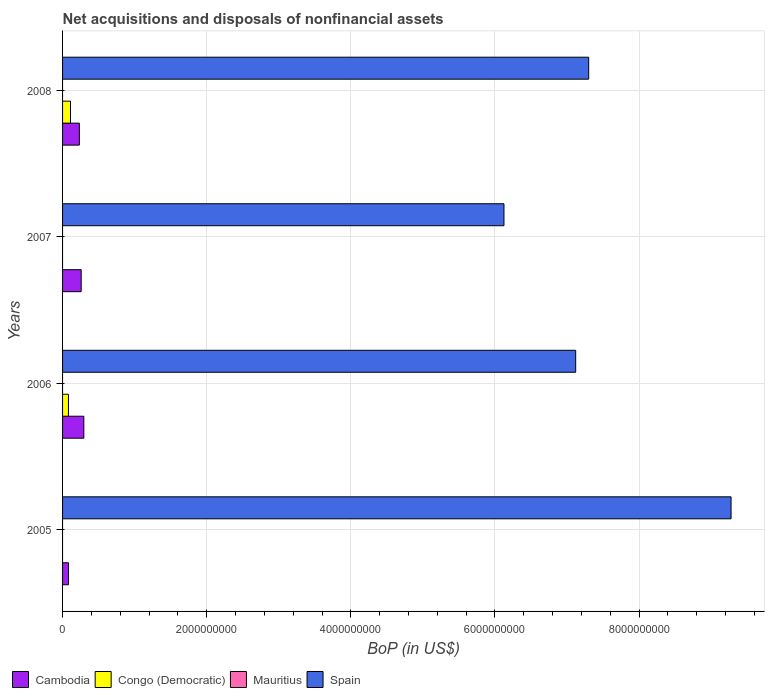How many groups of bars are there?
Ensure brevity in your answer.  4. Are the number of bars per tick equal to the number of legend labels?
Provide a short and direct response. No. How many bars are there on the 3rd tick from the bottom?
Offer a very short reply. 2. What is the label of the 3rd group of bars from the top?
Provide a succinct answer. 2006. In how many cases, is the number of bars for a given year not equal to the number of legend labels?
Keep it short and to the point. 4. What is the Balance of Payments in Congo (Democratic) in 2005?
Your answer should be very brief. 0. Across all years, what is the maximum Balance of Payments in Cambodia?
Offer a very short reply. 2.95e+08. Across all years, what is the minimum Balance of Payments in Spain?
Provide a short and direct response. 6.12e+09. In which year was the Balance of Payments in Cambodia maximum?
Your answer should be very brief. 2006. What is the total Balance of Payments in Spain in the graph?
Your answer should be compact. 2.98e+1. What is the difference between the Balance of Payments in Spain in 2007 and that in 2008?
Offer a terse response. -1.18e+09. What is the difference between the Balance of Payments in Mauritius in 2005 and the Balance of Payments in Congo (Democratic) in 2008?
Give a very brief answer. -1.10e+08. What is the average Balance of Payments in Spain per year?
Give a very brief answer. 7.46e+09. In the year 2008, what is the difference between the Balance of Payments in Spain and Balance of Payments in Cambodia?
Your answer should be compact. 7.07e+09. In how many years, is the Balance of Payments in Cambodia greater than 1600000000 US$?
Ensure brevity in your answer.  0. What is the ratio of the Balance of Payments in Spain in 2005 to that in 2008?
Your answer should be compact. 1.27. Is the difference between the Balance of Payments in Spain in 2005 and 2008 greater than the difference between the Balance of Payments in Cambodia in 2005 and 2008?
Your answer should be very brief. Yes. What is the difference between the highest and the second highest Balance of Payments in Cambodia?
Make the answer very short. 3.66e+07. What is the difference between the highest and the lowest Balance of Payments in Spain?
Give a very brief answer. 3.15e+09. In how many years, is the Balance of Payments in Spain greater than the average Balance of Payments in Spain taken over all years?
Give a very brief answer. 1. Is the sum of the Balance of Payments in Cambodia in 2005 and 2006 greater than the maximum Balance of Payments in Congo (Democratic) across all years?
Offer a terse response. Yes. How many years are there in the graph?
Offer a terse response. 4. What is the difference between two consecutive major ticks on the X-axis?
Your answer should be compact. 2.00e+09. Does the graph contain any zero values?
Provide a succinct answer. Yes. Does the graph contain grids?
Ensure brevity in your answer.  Yes. Where does the legend appear in the graph?
Ensure brevity in your answer.  Bottom left. How many legend labels are there?
Keep it short and to the point. 4. How are the legend labels stacked?
Ensure brevity in your answer.  Horizontal. What is the title of the graph?
Provide a short and direct response. Net acquisitions and disposals of nonfinancial assets. What is the label or title of the X-axis?
Keep it short and to the point. BoP (in US$). What is the label or title of the Y-axis?
Your answer should be compact. Years. What is the BoP (in US$) in Cambodia in 2005?
Give a very brief answer. 8.26e+07. What is the BoP (in US$) in Spain in 2005?
Ensure brevity in your answer.  9.28e+09. What is the BoP (in US$) of Cambodia in 2006?
Provide a succinct answer. 2.95e+08. What is the BoP (in US$) in Congo (Democratic) in 2006?
Ensure brevity in your answer.  8.17e+07. What is the BoP (in US$) in Mauritius in 2006?
Offer a very short reply. 0. What is the BoP (in US$) in Spain in 2006?
Provide a short and direct response. 7.12e+09. What is the BoP (in US$) in Cambodia in 2007?
Make the answer very short. 2.58e+08. What is the BoP (in US$) in Congo (Democratic) in 2007?
Your answer should be compact. 0. What is the BoP (in US$) in Spain in 2007?
Give a very brief answer. 6.12e+09. What is the BoP (in US$) of Cambodia in 2008?
Offer a very short reply. 2.33e+08. What is the BoP (in US$) in Congo (Democratic) in 2008?
Give a very brief answer. 1.10e+08. What is the BoP (in US$) in Spain in 2008?
Offer a terse response. 7.30e+09. Across all years, what is the maximum BoP (in US$) of Cambodia?
Offer a very short reply. 2.95e+08. Across all years, what is the maximum BoP (in US$) of Congo (Democratic)?
Keep it short and to the point. 1.10e+08. Across all years, what is the maximum BoP (in US$) in Spain?
Your answer should be compact. 9.28e+09. Across all years, what is the minimum BoP (in US$) in Cambodia?
Provide a short and direct response. 8.26e+07. Across all years, what is the minimum BoP (in US$) in Congo (Democratic)?
Provide a succinct answer. 0. Across all years, what is the minimum BoP (in US$) of Spain?
Your answer should be compact. 6.12e+09. What is the total BoP (in US$) of Cambodia in the graph?
Provide a short and direct response. 8.69e+08. What is the total BoP (in US$) of Congo (Democratic) in the graph?
Your answer should be very brief. 1.92e+08. What is the total BoP (in US$) in Spain in the graph?
Offer a terse response. 2.98e+1. What is the difference between the BoP (in US$) in Cambodia in 2005 and that in 2006?
Offer a very short reply. -2.12e+08. What is the difference between the BoP (in US$) of Spain in 2005 and that in 2006?
Your answer should be very brief. 2.16e+09. What is the difference between the BoP (in US$) in Cambodia in 2005 and that in 2007?
Your answer should be very brief. -1.76e+08. What is the difference between the BoP (in US$) in Spain in 2005 and that in 2007?
Make the answer very short. 3.15e+09. What is the difference between the BoP (in US$) in Cambodia in 2005 and that in 2008?
Ensure brevity in your answer.  -1.50e+08. What is the difference between the BoP (in US$) of Spain in 2005 and that in 2008?
Provide a short and direct response. 1.98e+09. What is the difference between the BoP (in US$) of Cambodia in 2006 and that in 2007?
Your answer should be compact. 3.66e+07. What is the difference between the BoP (in US$) in Spain in 2006 and that in 2007?
Provide a succinct answer. 9.95e+08. What is the difference between the BoP (in US$) of Cambodia in 2006 and that in 2008?
Give a very brief answer. 6.22e+07. What is the difference between the BoP (in US$) of Congo (Democratic) in 2006 and that in 2008?
Your answer should be very brief. -2.84e+07. What is the difference between the BoP (in US$) in Spain in 2006 and that in 2008?
Your response must be concise. -1.81e+08. What is the difference between the BoP (in US$) of Cambodia in 2007 and that in 2008?
Ensure brevity in your answer.  2.56e+07. What is the difference between the BoP (in US$) in Spain in 2007 and that in 2008?
Make the answer very short. -1.18e+09. What is the difference between the BoP (in US$) of Cambodia in 2005 and the BoP (in US$) of Congo (Democratic) in 2006?
Provide a succinct answer. 8.53e+05. What is the difference between the BoP (in US$) of Cambodia in 2005 and the BoP (in US$) of Spain in 2006?
Give a very brief answer. -7.04e+09. What is the difference between the BoP (in US$) in Cambodia in 2005 and the BoP (in US$) in Spain in 2007?
Keep it short and to the point. -6.04e+09. What is the difference between the BoP (in US$) of Cambodia in 2005 and the BoP (in US$) of Congo (Democratic) in 2008?
Your answer should be compact. -2.75e+07. What is the difference between the BoP (in US$) of Cambodia in 2005 and the BoP (in US$) of Spain in 2008?
Provide a short and direct response. -7.22e+09. What is the difference between the BoP (in US$) in Cambodia in 2006 and the BoP (in US$) in Spain in 2007?
Offer a very short reply. -5.83e+09. What is the difference between the BoP (in US$) in Congo (Democratic) in 2006 and the BoP (in US$) in Spain in 2007?
Your response must be concise. -6.04e+09. What is the difference between the BoP (in US$) in Cambodia in 2006 and the BoP (in US$) in Congo (Democratic) in 2008?
Offer a very short reply. 1.85e+08. What is the difference between the BoP (in US$) of Cambodia in 2006 and the BoP (in US$) of Spain in 2008?
Keep it short and to the point. -7.01e+09. What is the difference between the BoP (in US$) of Congo (Democratic) in 2006 and the BoP (in US$) of Spain in 2008?
Give a very brief answer. -7.22e+09. What is the difference between the BoP (in US$) in Cambodia in 2007 and the BoP (in US$) in Congo (Democratic) in 2008?
Ensure brevity in your answer.  1.48e+08. What is the difference between the BoP (in US$) in Cambodia in 2007 and the BoP (in US$) in Spain in 2008?
Offer a very short reply. -7.04e+09. What is the average BoP (in US$) of Cambodia per year?
Ensure brevity in your answer.  2.17e+08. What is the average BoP (in US$) of Congo (Democratic) per year?
Provide a short and direct response. 4.80e+07. What is the average BoP (in US$) in Mauritius per year?
Your answer should be very brief. 0. What is the average BoP (in US$) in Spain per year?
Provide a short and direct response. 7.46e+09. In the year 2005, what is the difference between the BoP (in US$) in Cambodia and BoP (in US$) in Spain?
Your answer should be very brief. -9.19e+09. In the year 2006, what is the difference between the BoP (in US$) in Cambodia and BoP (in US$) in Congo (Democratic)?
Keep it short and to the point. 2.13e+08. In the year 2006, what is the difference between the BoP (in US$) of Cambodia and BoP (in US$) of Spain?
Keep it short and to the point. -6.83e+09. In the year 2006, what is the difference between the BoP (in US$) of Congo (Democratic) and BoP (in US$) of Spain?
Offer a very short reply. -7.04e+09. In the year 2007, what is the difference between the BoP (in US$) of Cambodia and BoP (in US$) of Spain?
Keep it short and to the point. -5.87e+09. In the year 2008, what is the difference between the BoP (in US$) of Cambodia and BoP (in US$) of Congo (Democratic)?
Your answer should be compact. 1.23e+08. In the year 2008, what is the difference between the BoP (in US$) of Cambodia and BoP (in US$) of Spain?
Your response must be concise. -7.07e+09. In the year 2008, what is the difference between the BoP (in US$) of Congo (Democratic) and BoP (in US$) of Spain?
Your response must be concise. -7.19e+09. What is the ratio of the BoP (in US$) in Cambodia in 2005 to that in 2006?
Your answer should be very brief. 0.28. What is the ratio of the BoP (in US$) of Spain in 2005 to that in 2006?
Offer a terse response. 1.3. What is the ratio of the BoP (in US$) of Cambodia in 2005 to that in 2007?
Keep it short and to the point. 0.32. What is the ratio of the BoP (in US$) in Spain in 2005 to that in 2007?
Give a very brief answer. 1.51. What is the ratio of the BoP (in US$) in Cambodia in 2005 to that in 2008?
Your answer should be very brief. 0.35. What is the ratio of the BoP (in US$) of Spain in 2005 to that in 2008?
Your answer should be very brief. 1.27. What is the ratio of the BoP (in US$) in Cambodia in 2006 to that in 2007?
Give a very brief answer. 1.14. What is the ratio of the BoP (in US$) of Spain in 2006 to that in 2007?
Your response must be concise. 1.16. What is the ratio of the BoP (in US$) of Cambodia in 2006 to that in 2008?
Your answer should be compact. 1.27. What is the ratio of the BoP (in US$) in Congo (Democratic) in 2006 to that in 2008?
Make the answer very short. 0.74. What is the ratio of the BoP (in US$) in Spain in 2006 to that in 2008?
Offer a very short reply. 0.98. What is the ratio of the BoP (in US$) of Cambodia in 2007 to that in 2008?
Make the answer very short. 1.11. What is the ratio of the BoP (in US$) in Spain in 2007 to that in 2008?
Keep it short and to the point. 0.84. What is the difference between the highest and the second highest BoP (in US$) in Cambodia?
Keep it short and to the point. 3.66e+07. What is the difference between the highest and the second highest BoP (in US$) in Spain?
Offer a terse response. 1.98e+09. What is the difference between the highest and the lowest BoP (in US$) in Cambodia?
Provide a short and direct response. 2.12e+08. What is the difference between the highest and the lowest BoP (in US$) of Congo (Democratic)?
Provide a succinct answer. 1.10e+08. What is the difference between the highest and the lowest BoP (in US$) of Spain?
Give a very brief answer. 3.15e+09. 